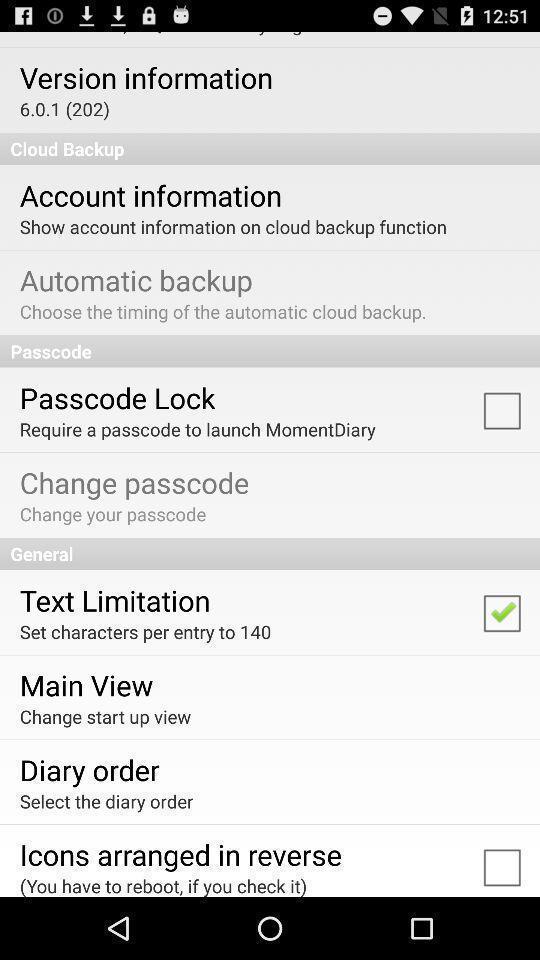Please provide a description for this image. Social app showing list of information. 